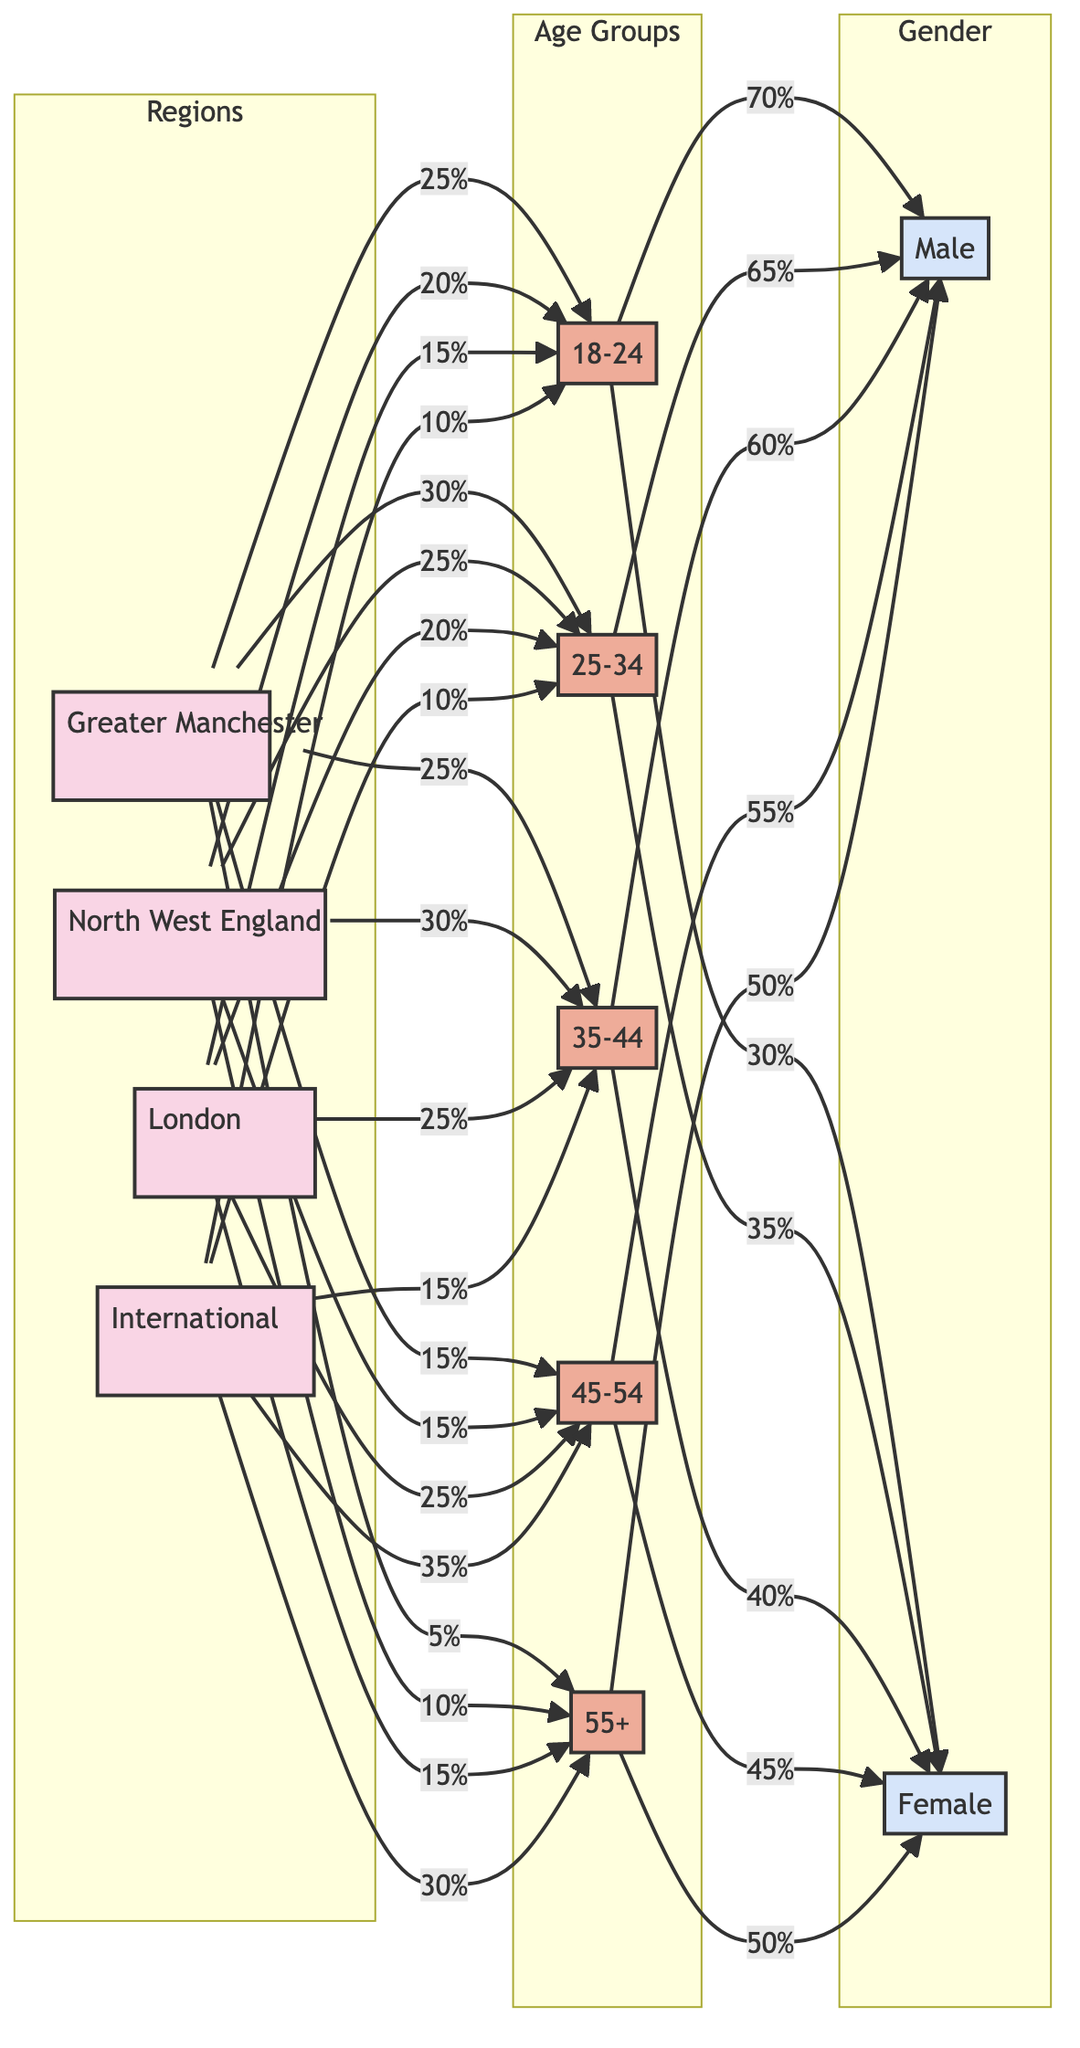What age group has the highest percentage of fans from Greater Manchester? By examining the flow from the Greater Manchester node, it shows that the largest proportion, 30%, belongs to the 25-34 age group.
Answer: 25-34 What percentage of international fans are aged 45-54? Looking at the International node, 35% of international fans belong to the 45-54 age group.
Answer: 35% Which gender is more prevalent in the 18-24 age group? From the 18-24 age group node, it states that 70% of fans are male and 30% are female, indicating that more males are present.
Answer: Male What is the total percentage of fans aged 35-44 from the North West England region? By following the North West England node to the age group connections, 30% of Norht West England fans are in the 35-44 age group.
Answer: 30% How many age groups are represented in the diagram? The diagram contains five distinct age groups that are visually presented.
Answer: 5 Which region has the lowest percentage of fans in the 18-24 age group? Analyzing the 18-24 connections, the International region has only 10% of fans aged 18-24, the lowest proportion compared to the others.
Answer: International 